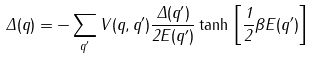<formula> <loc_0><loc_0><loc_500><loc_500>\Delta ( { q } ) = - \sum _ { { q } ^ { \prime } } V ( { q } , { q } ^ { \prime } ) \frac { \Delta ( { q } ^ { \prime } ) } { 2 E ( { q } ^ { \prime } ) } \tanh \, \left [ \frac { 1 } { 2 } \beta E ( { q } ^ { \prime } ) \right ] \\</formula> 